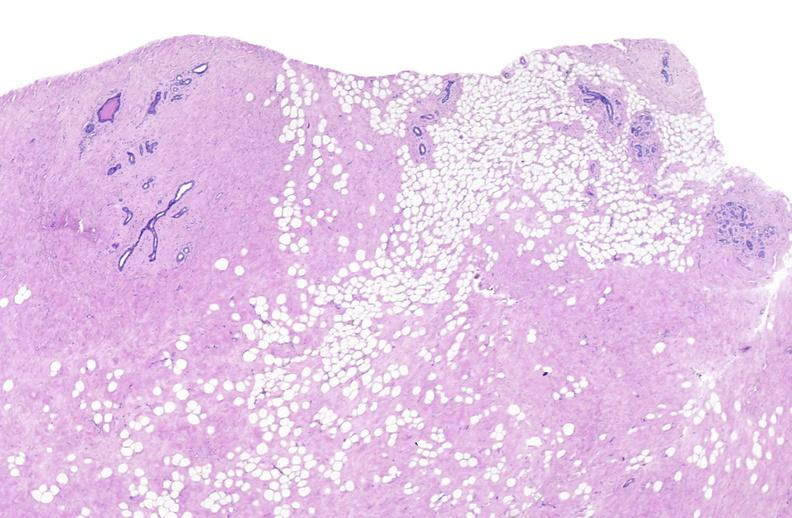what does this image show?
Answer the question using a single word or phrase. Breast 